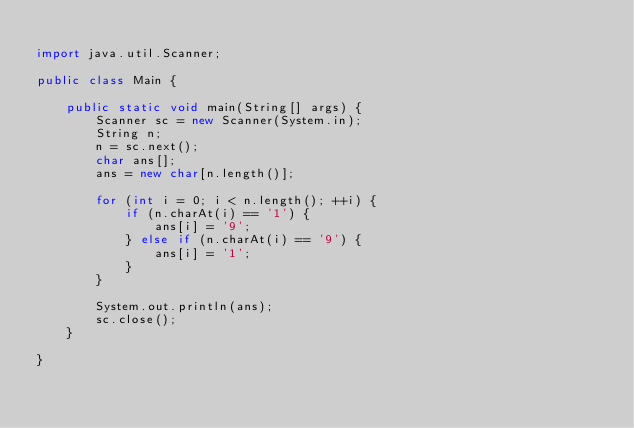Convert code to text. <code><loc_0><loc_0><loc_500><loc_500><_Java_>
import java.util.Scanner;

public class Main {

	public static void main(String[] args) {
		Scanner sc = new Scanner(System.in);
		String n;
		n = sc.next();
		char ans[];
		ans = new char[n.length()];

		for (int i = 0; i < n.length(); ++i) {
			if (n.charAt(i) == '1') {
				ans[i] = '9';
			} else if (n.charAt(i) == '9') {
				ans[i] = '1';
			}
		}

		System.out.println(ans);
		sc.close();
	}

}
</code> 